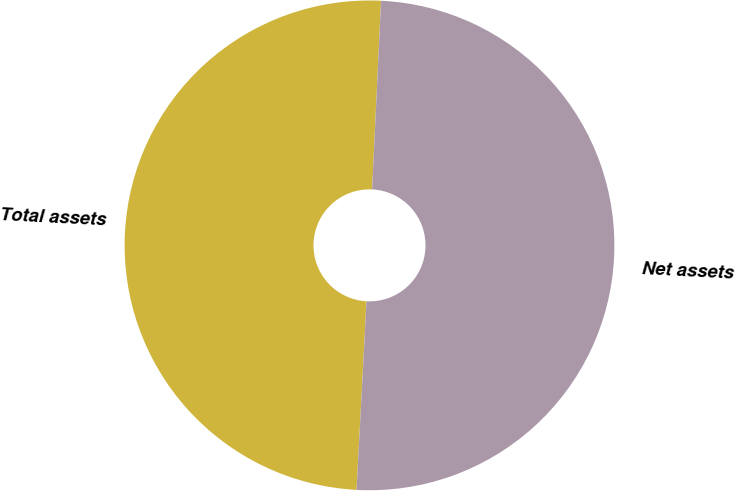Convert chart to OTSL. <chart><loc_0><loc_0><loc_500><loc_500><pie_chart><fcel>Total assets<fcel>Net assets<nl><fcel>49.91%<fcel>50.09%<nl></chart> 